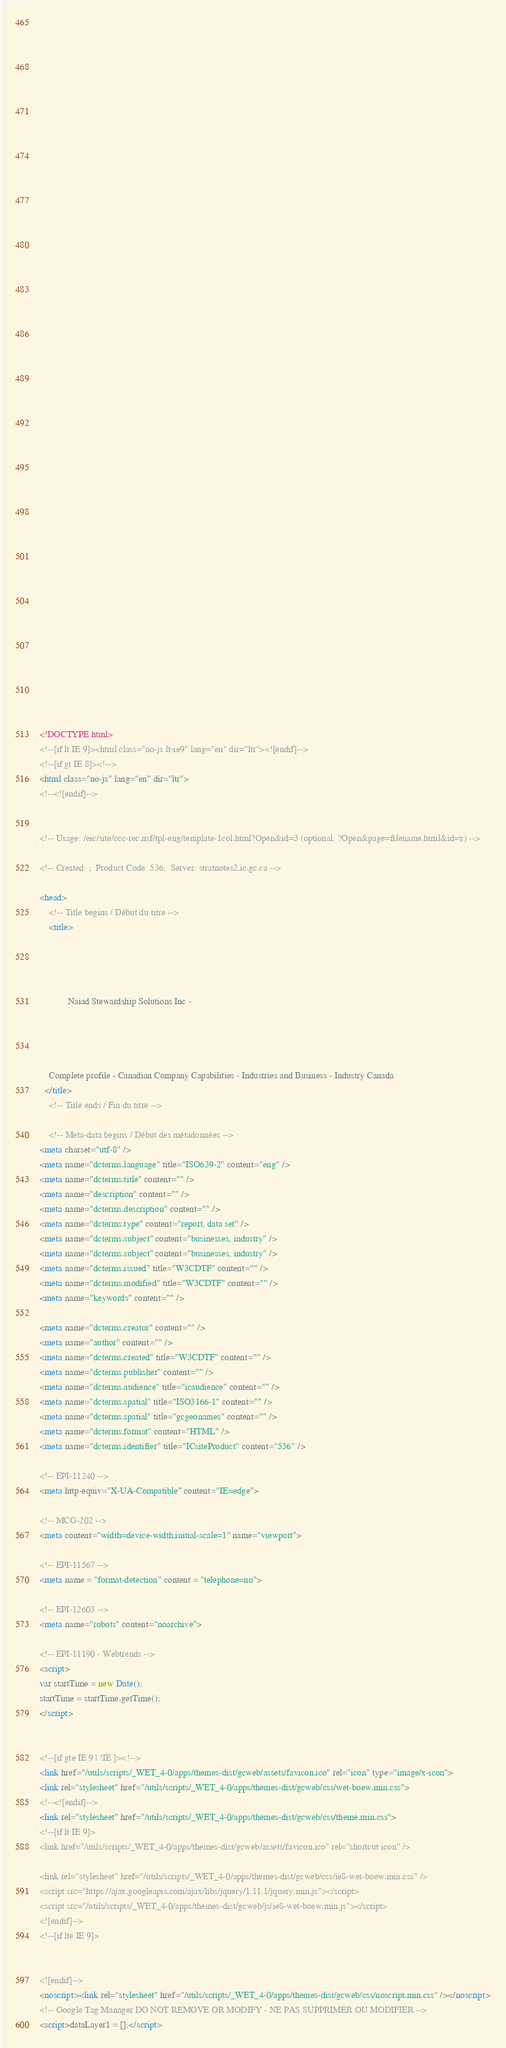Convert code to text. <code><loc_0><loc_0><loc_500><loc_500><_HTML_>


















	






  
  
  
  































	
	
	



<!DOCTYPE html>
<!--[if lt IE 9]><html class="no-js lt-ie9" lang="en" dir="ltr"><![endif]-->
<!--[if gt IE 8]><!-->
<html class="no-js" lang="en" dir="ltr">
<!--<![endif]-->


<!-- Usage: /eic/site/ccc-rec.nsf/tpl-eng/template-1col.html?Open&id=3 (optional: ?Open&page=filename.html&id=x) -->

<!-- Created: ;  Product Code: 536;  Server: stratnotes2.ic.gc.ca -->

<head>
	<!-- Title begins / Début du titre -->
	<title>
    
            
        
          
            Naiad Stewardship Solutions Inc -
          
        
      
    
    Complete profile - Canadian Company Capabilities - Industries and Business - Industry Canada
  </title>
	<!-- Title ends / Fin du titre -->
 
	<!-- Meta-data begins / Début des métadonnées -->
<meta charset="utf-8" />
<meta name="dcterms.language" title="ISO639-2" content="eng" />
<meta name="dcterms.title" content="" />
<meta name="description" content="" />
<meta name="dcterms.description" content="" />
<meta name="dcterms.type" content="report, data set" />
<meta name="dcterms.subject" content="businesses, industry" />
<meta name="dcterms.subject" content="businesses, industry" />
<meta name="dcterms.issued" title="W3CDTF" content="" />
<meta name="dcterms.modified" title="W3CDTF" content="" />
<meta name="keywords" content="" />

<meta name="dcterms.creator" content="" />
<meta name="author" content="" />
<meta name="dcterms.created" title="W3CDTF" content="" />
<meta name="dcterms.publisher" content="" />
<meta name="dcterms.audience" title="icaudience" content="" />
<meta name="dcterms.spatial" title="ISO3166-1" content="" />
<meta name="dcterms.spatial" title="gcgeonames" content="" />
<meta name="dcterms.format" content="HTML" />
<meta name="dcterms.identifier" title="ICsiteProduct" content="536" />

<!-- EPI-11240 -->
<meta http-equiv="X-UA-Compatible" content="IE=edge">

<!-- MCG-202 -->
<meta content="width=device-width,initial-scale=1" name="viewport">

<!-- EPI-11567 -->
<meta name = "format-detection" content = "telephone=no">

<!-- EPI-12603 -->
<meta name="robots" content="noarchive">

<!-- EPI-11190 - Webtrends -->
<script>
var startTime = new Date();
startTime = startTime.getTime();
</script>


<!--[if gte IE 9 | !IE ]><!-->
<link href="/utils/scripts/_WET_4-0/apps/themes-dist/gcweb/assets/favicon.ico" rel="icon" type="image/x-icon">
<link rel="stylesheet" href="/utils/scripts/_WET_4-0/apps/themes-dist/gcweb/css/wet-boew.min.css">
<!--<![endif]-->
<link rel="stylesheet" href="/utils/scripts/_WET_4-0/apps/themes-dist/gcweb/css/theme.min.css">
<!--[if lt IE 9]>
<link href="/utils/scripts/_WET_4-0/apps/themes-dist/gcweb/assets/favicon.ico" rel="shortcut icon" />

<link rel="stylesheet" href="/utils/scripts/_WET_4-0/apps/themes-dist/gcweb/css/ie8-wet-boew.min.css" />
<script src="https://ajax.googleapis.com/ajax/libs/jquery/1.11.1/jquery.min.js"></script>
<script src="/utils/scripts/_WET_4-0/apps/themes-dist/gcweb/js/ie8-wet-boew.min.js"></script>
<![endif]-->
<!--[if lte IE 9]>


<![endif]-->
<noscript><link rel="stylesheet" href="/utils/scripts/_WET_4-0/apps/themes-dist/gcweb/css/noscript.min.css" /></noscript>
<!-- Google Tag Manager DO NOT REMOVE OR MODIFY - NE PAS SUPPRIMER OU MODIFIER -->
<script>dataLayer1 = [];</script></code> 